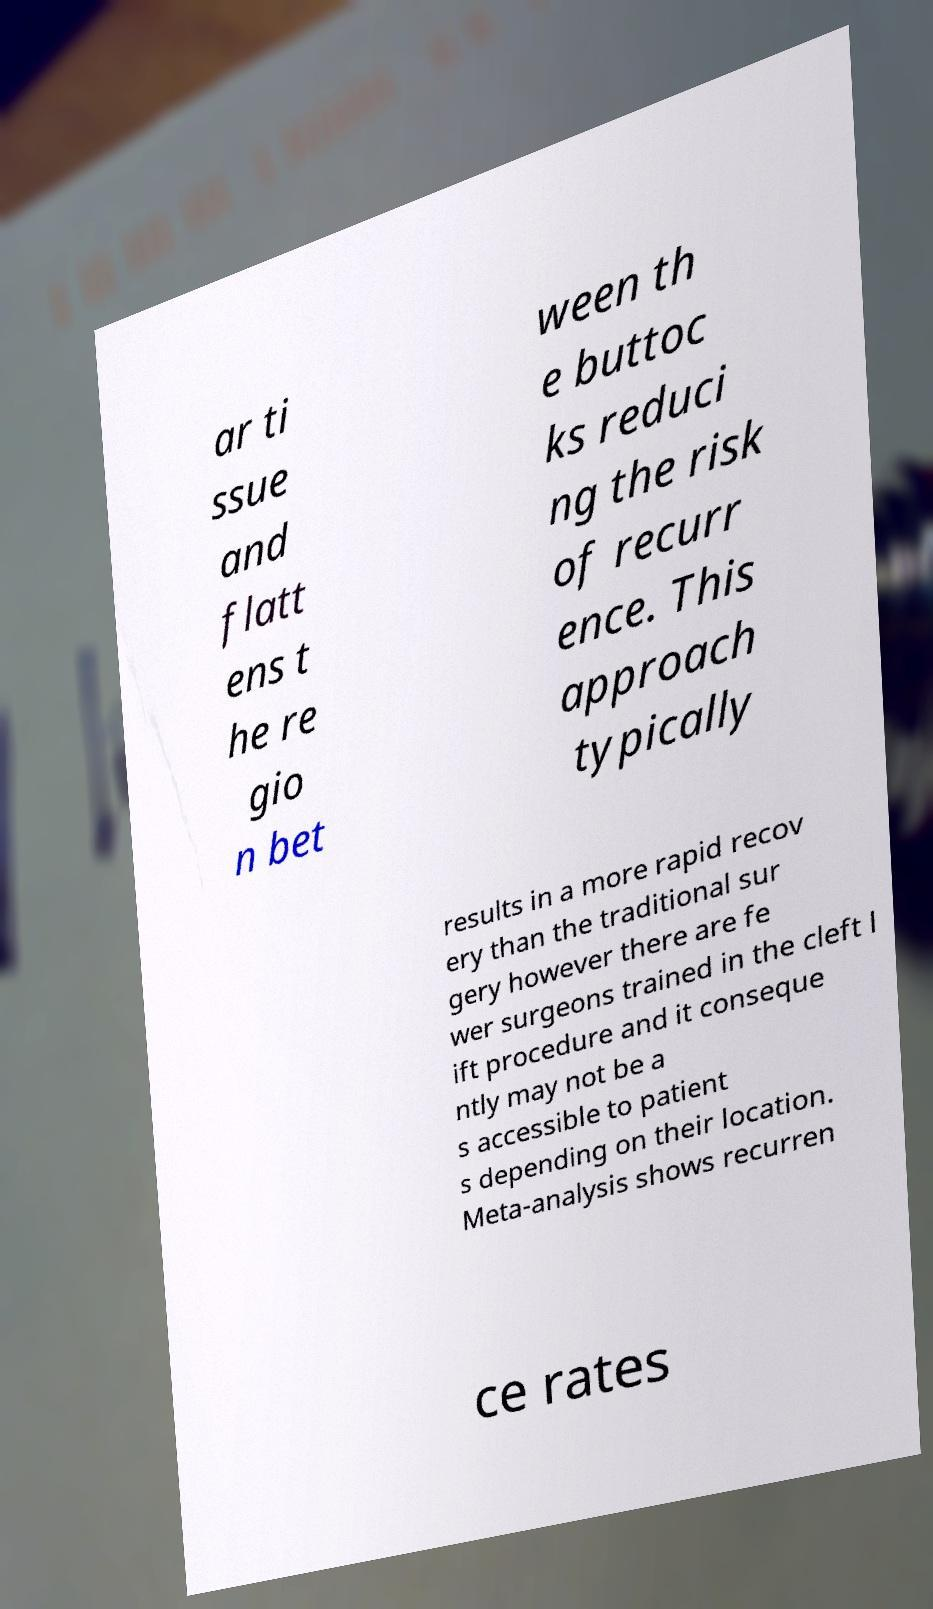Please identify and transcribe the text found in this image. ar ti ssue and flatt ens t he re gio n bet ween th e buttoc ks reduci ng the risk of recurr ence. This approach typically results in a more rapid recov ery than the traditional sur gery however there are fe wer surgeons trained in the cleft l ift procedure and it conseque ntly may not be a s accessible to patient s depending on their location. Meta-analysis shows recurren ce rates 